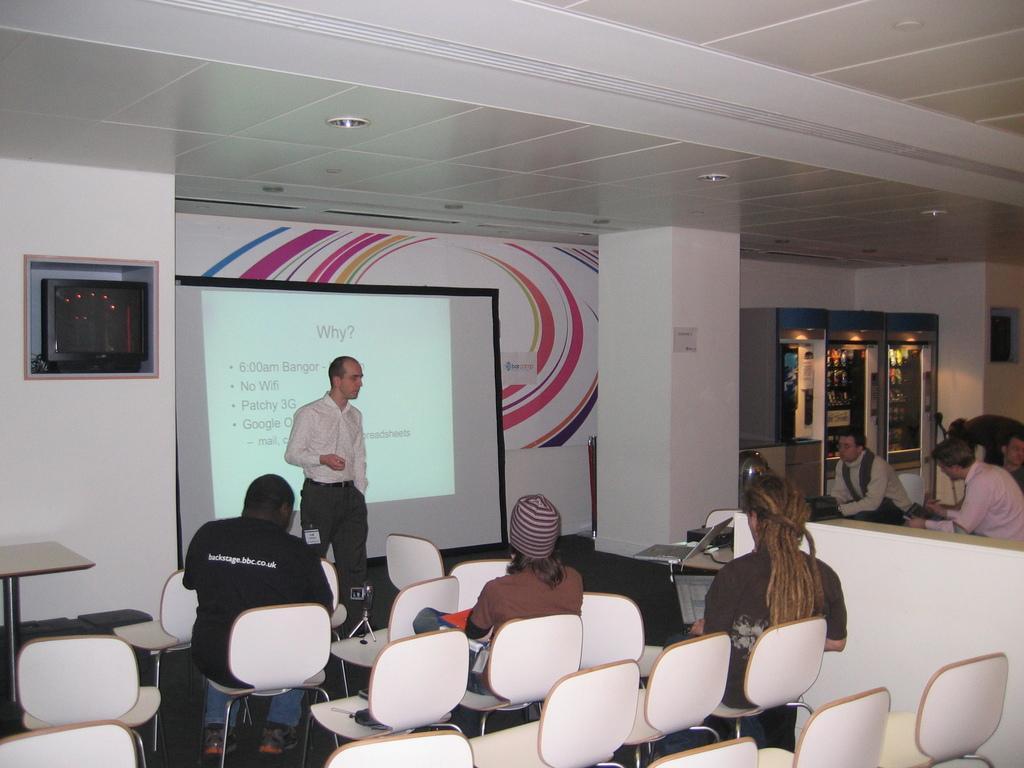How would you summarize this image in a sentence or two? In this image I see few people who are sitting on chairs and this man is standing over here, I can also see few more chairs and on this table I see a laptop. In the background I see vending machines, wall and a projector screen over here. 